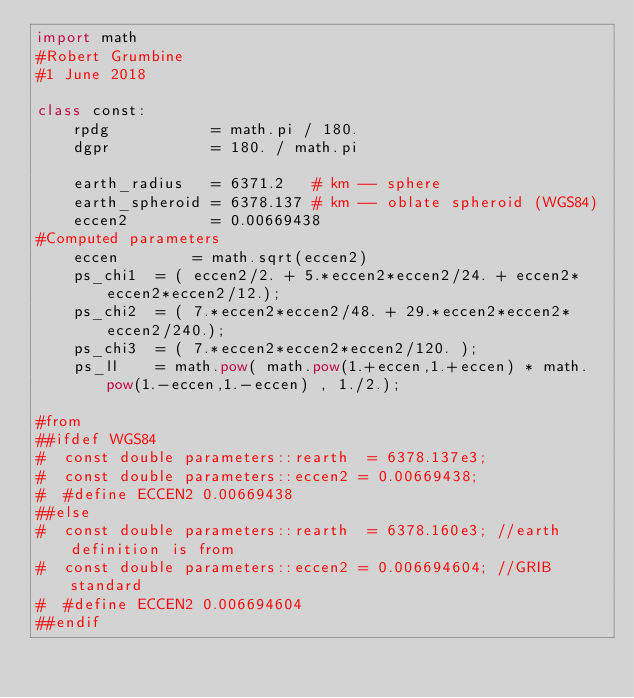<code> <loc_0><loc_0><loc_500><loc_500><_Python_>import math
#Robert Grumbine
#1 June 2018

class const:
    rpdg           = math.pi / 180.
    dgpr           = 180. / math.pi

    earth_radius   = 6371.2   # km -- sphere
    earth_spheroid = 6378.137 # km -- oblate spheroid (WGS84)
    eccen2         = 0.00669438
#Computed parameters
    eccen        = math.sqrt(eccen2)
    ps_chi1  = ( eccen2/2. + 5.*eccen2*eccen2/24. + eccen2*eccen2*eccen2/12.);
    ps_chi2  = ( 7.*eccen2*eccen2/48. + 29.*eccen2*eccen2*eccen2/240.);
    ps_chi3  = ( 7.*eccen2*eccen2*eccen2/120. );
    ps_ll    = math.pow( math.pow(1.+eccen,1.+eccen) * math.pow(1.-eccen,1.-eccen) , 1./2.);

#from 
##ifdef WGS84
#  const double parameters::rearth  = 6378.137e3;
#  const double parameters::eccen2 = 0.00669438;
#  #define ECCEN2 0.00669438
##else
#  const double parameters::rearth  = 6378.160e3; //earth definition is from
#  const double parameters::eccen2 = 0.006694604; //GRIB standard
#  #define ECCEN2 0.006694604
##endif
</code> 